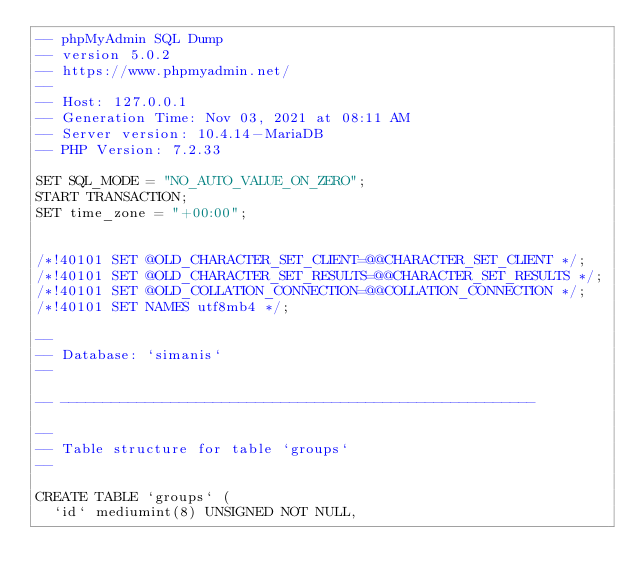Convert code to text. <code><loc_0><loc_0><loc_500><loc_500><_SQL_>-- phpMyAdmin SQL Dump
-- version 5.0.2
-- https://www.phpmyadmin.net/
--
-- Host: 127.0.0.1
-- Generation Time: Nov 03, 2021 at 08:11 AM
-- Server version: 10.4.14-MariaDB
-- PHP Version: 7.2.33

SET SQL_MODE = "NO_AUTO_VALUE_ON_ZERO";
START TRANSACTION;
SET time_zone = "+00:00";


/*!40101 SET @OLD_CHARACTER_SET_CLIENT=@@CHARACTER_SET_CLIENT */;
/*!40101 SET @OLD_CHARACTER_SET_RESULTS=@@CHARACTER_SET_RESULTS */;
/*!40101 SET @OLD_COLLATION_CONNECTION=@@COLLATION_CONNECTION */;
/*!40101 SET NAMES utf8mb4 */;

--
-- Database: `simanis`
--

-- --------------------------------------------------------

--
-- Table structure for table `groups`
--

CREATE TABLE `groups` (
  `id` mediumint(8) UNSIGNED NOT NULL,</code> 